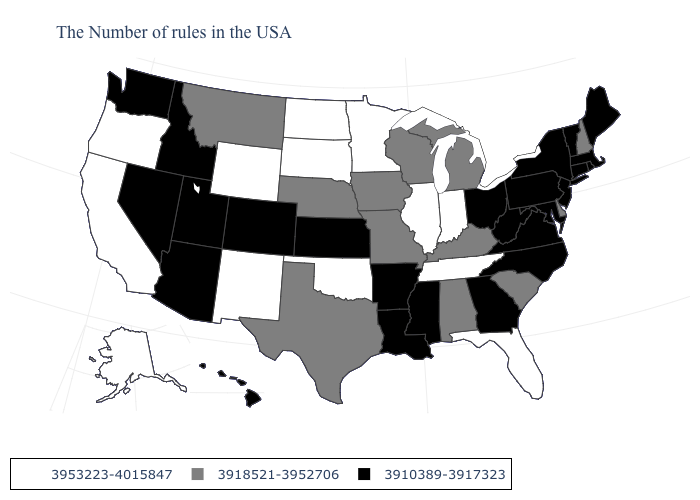What is the value of Ohio?
Give a very brief answer. 3910389-3917323. What is the value of Tennessee?
Keep it brief. 3953223-4015847. Name the states that have a value in the range 3910389-3917323?
Keep it brief. Maine, Massachusetts, Rhode Island, Vermont, Connecticut, New York, New Jersey, Maryland, Pennsylvania, Virginia, North Carolina, West Virginia, Ohio, Georgia, Mississippi, Louisiana, Arkansas, Kansas, Colorado, Utah, Arizona, Idaho, Nevada, Washington, Hawaii. What is the highest value in the USA?
Quick response, please. 3953223-4015847. Does Colorado have the lowest value in the West?
Give a very brief answer. Yes. What is the lowest value in states that border Illinois?
Give a very brief answer. 3918521-3952706. Name the states that have a value in the range 3953223-4015847?
Quick response, please. Florida, Indiana, Tennessee, Illinois, Minnesota, Oklahoma, South Dakota, North Dakota, Wyoming, New Mexico, California, Oregon, Alaska. Name the states that have a value in the range 3910389-3917323?
Short answer required. Maine, Massachusetts, Rhode Island, Vermont, Connecticut, New York, New Jersey, Maryland, Pennsylvania, Virginia, North Carolina, West Virginia, Ohio, Georgia, Mississippi, Louisiana, Arkansas, Kansas, Colorado, Utah, Arizona, Idaho, Nevada, Washington, Hawaii. Does the map have missing data?
Short answer required. No. Among the states that border West Virginia , which have the lowest value?
Write a very short answer. Maryland, Pennsylvania, Virginia, Ohio. What is the highest value in the Northeast ?
Answer briefly. 3918521-3952706. Is the legend a continuous bar?
Write a very short answer. No. Is the legend a continuous bar?
Answer briefly. No. How many symbols are there in the legend?
Short answer required. 3. Does Maryland have the same value as Minnesota?
Be succinct. No. 